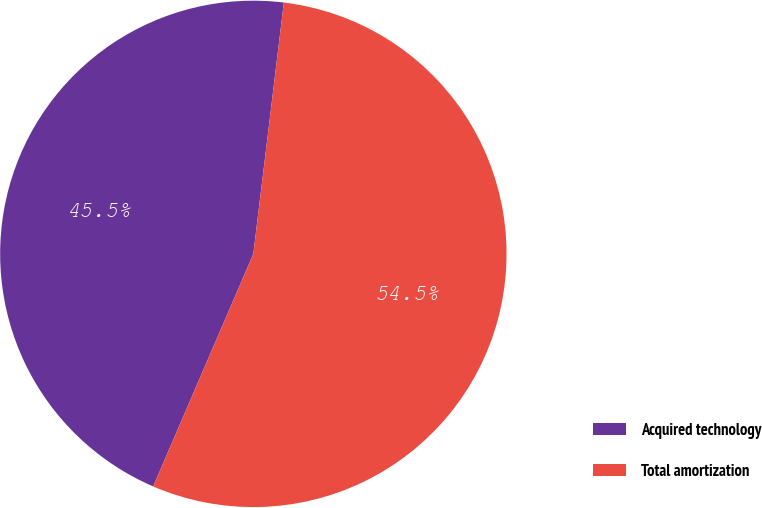Convert chart. <chart><loc_0><loc_0><loc_500><loc_500><pie_chart><fcel>Acquired technology<fcel>Total amortization<nl><fcel>45.45%<fcel>54.55%<nl></chart> 